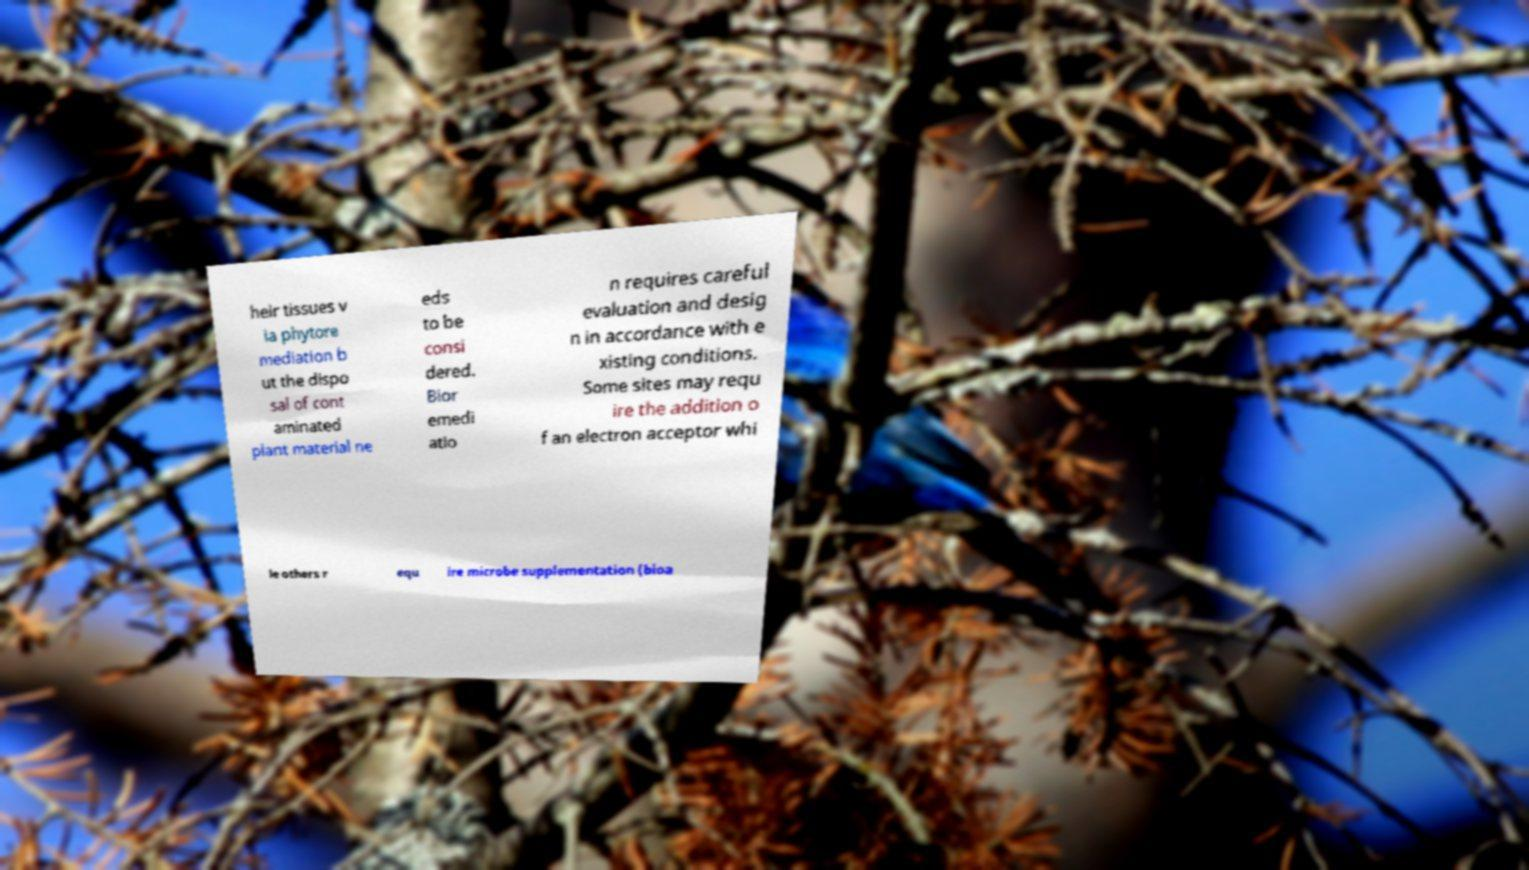Can you read and provide the text displayed in the image?This photo seems to have some interesting text. Can you extract and type it out for me? heir tissues v ia phytore mediation b ut the dispo sal of cont aminated plant material ne eds to be consi dered. Bior emedi atio n requires careful evaluation and desig n in accordance with e xisting conditions. Some sites may requ ire the addition o f an electron acceptor whi le others r equ ire microbe supplementation (bioa 